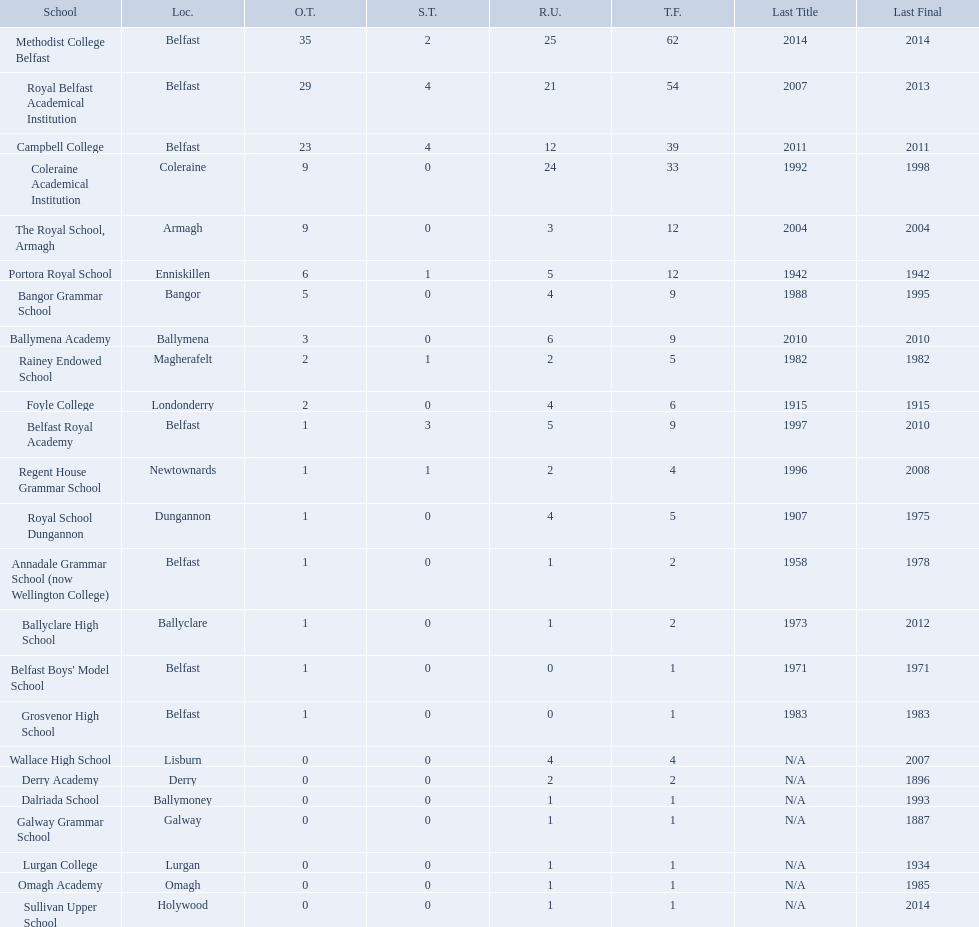What were all of the school names? Methodist College Belfast, Royal Belfast Academical Institution, Campbell College, Coleraine Academical Institution, The Royal School, Armagh, Portora Royal School, Bangor Grammar School, Ballymena Academy, Rainey Endowed School, Foyle College, Belfast Royal Academy, Regent House Grammar School, Royal School Dungannon, Annadale Grammar School (now Wellington College), Ballyclare High School, Belfast Boys' Model School, Grosvenor High School, Wallace High School, Derry Academy, Dalriada School, Galway Grammar School, Lurgan College, Omagh Academy, Sullivan Upper School. How many outright titles did they achieve? 35, 29, 23, 9, 9, 6, 5, 3, 2, 2, 1, 1, 1, 1, 1, 1, 1, 0, 0, 0, 0, 0, 0, 0. And how many did coleraine academical institution receive? 9. Which other school had the same number of outright titles? The Royal School, Armagh. How many schools are there? Methodist College Belfast, Royal Belfast Academical Institution, Campbell College, Coleraine Academical Institution, The Royal School, Armagh, Portora Royal School, Bangor Grammar School, Ballymena Academy, Rainey Endowed School, Foyle College, Belfast Royal Academy, Regent House Grammar School, Royal School Dungannon, Annadale Grammar School (now Wellington College), Ballyclare High School, Belfast Boys' Model School, Grosvenor High School, Wallace High School, Derry Academy, Dalriada School, Galway Grammar School, Lurgan College, Omagh Academy, Sullivan Upper School. How many outright titles does the coleraine academical institution have? 9. What other school has the same number of outright titles? The Royal School, Armagh. Which schools are listed? Methodist College Belfast, Royal Belfast Academical Institution, Campbell College, Coleraine Academical Institution, The Royal School, Armagh, Portora Royal School, Bangor Grammar School, Ballymena Academy, Rainey Endowed School, Foyle College, Belfast Royal Academy, Regent House Grammar School, Royal School Dungannon, Annadale Grammar School (now Wellington College), Ballyclare High School, Belfast Boys' Model School, Grosvenor High School, Wallace High School, Derry Academy, Dalriada School, Galway Grammar School, Lurgan College, Omagh Academy, Sullivan Upper School. When did campbell college win the title last? 2011. When did regent house grammar school win the title last? 1996. Of those two who had the most recent title win? Campbell College. Which colleges participated in the ulster's schools' cup? Methodist College Belfast, Royal Belfast Academical Institution, Campbell College, Coleraine Academical Institution, The Royal School, Armagh, Portora Royal School, Bangor Grammar School, Ballymena Academy, Rainey Endowed School, Foyle College, Belfast Royal Academy, Regent House Grammar School, Royal School Dungannon, Annadale Grammar School (now Wellington College), Ballyclare High School, Belfast Boys' Model School, Grosvenor High School, Wallace High School, Derry Academy, Dalriada School, Galway Grammar School, Lurgan College, Omagh Academy, Sullivan Upper School. Of these, which are from belfast? Methodist College Belfast, Royal Belfast Academical Institution, Campbell College, Belfast Royal Academy, Annadale Grammar School (now Wellington College), Belfast Boys' Model School, Grosvenor High School. Of these, which have more than 20 outright titles? Methodist College Belfast, Royal Belfast Academical Institution, Campbell College. Which of these have the fewest runners-up? Campbell College. What is the most recent win of campbell college? 2011. What is the most recent win of regent house grammar school? 1996. Which date is more recent? 2011. What is the name of the school with this date? Campbell College. 